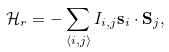Convert formula to latex. <formula><loc_0><loc_0><loc_500><loc_500>\mathcal { H } _ { r } = - \sum _ { \left < i , j \right > } I _ { i , j } \mathbf s _ { i } \cdot \mathbf S _ { j } ,</formula> 